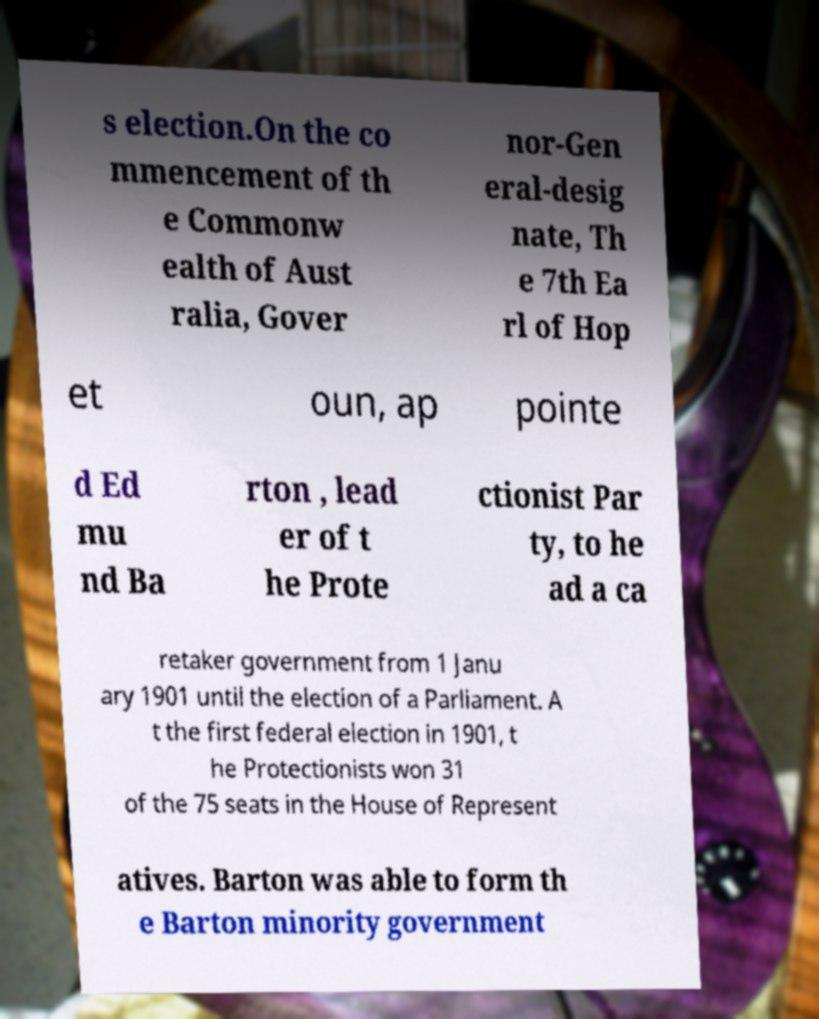Could you assist in decoding the text presented in this image and type it out clearly? s election.On the co mmencement of th e Commonw ealth of Aust ralia, Gover nor-Gen eral-desig nate, Th e 7th Ea rl of Hop et oun, ap pointe d Ed mu nd Ba rton , lead er of t he Prote ctionist Par ty, to he ad a ca retaker government from 1 Janu ary 1901 until the election of a Parliament. A t the first federal election in 1901, t he Protectionists won 31 of the 75 seats in the House of Represent atives. Barton was able to form th e Barton minority government 